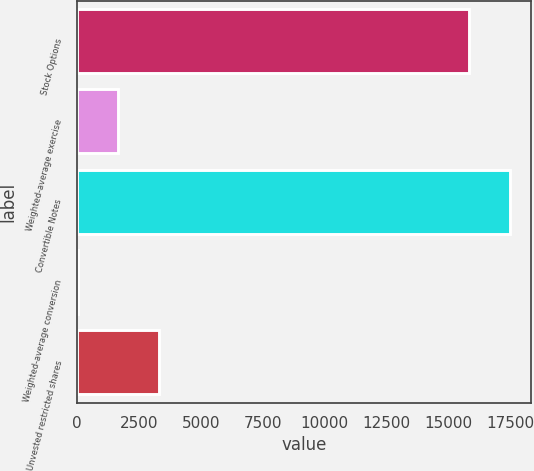<chart> <loc_0><loc_0><loc_500><loc_500><bar_chart><fcel>Stock Options<fcel>Weighted-average exercise<fcel>Convertible Notes<fcel>Weighted-average conversion<fcel>Unvested restricted shares<nl><fcel>15820<fcel>1662.63<fcel>17463.5<fcel>19.15<fcel>3306.11<nl></chart> 